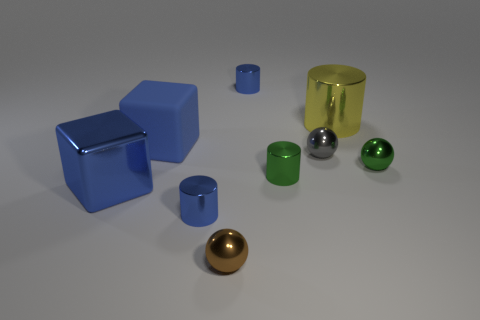Subtract all gray balls. How many balls are left? 2 Subtract all brown spheres. How many spheres are left? 2 Subtract all spheres. How many objects are left? 6 Subtract 2 blocks. How many blocks are left? 0 Subtract all purple cylinders. Subtract all red balls. How many cylinders are left? 4 Subtract all brown cylinders. How many gray spheres are left? 1 Subtract all brown shiny things. Subtract all blue cubes. How many objects are left? 6 Add 6 blue cubes. How many blue cubes are left? 8 Add 7 brown shiny spheres. How many brown shiny spheres exist? 8 Subtract 1 green spheres. How many objects are left? 8 